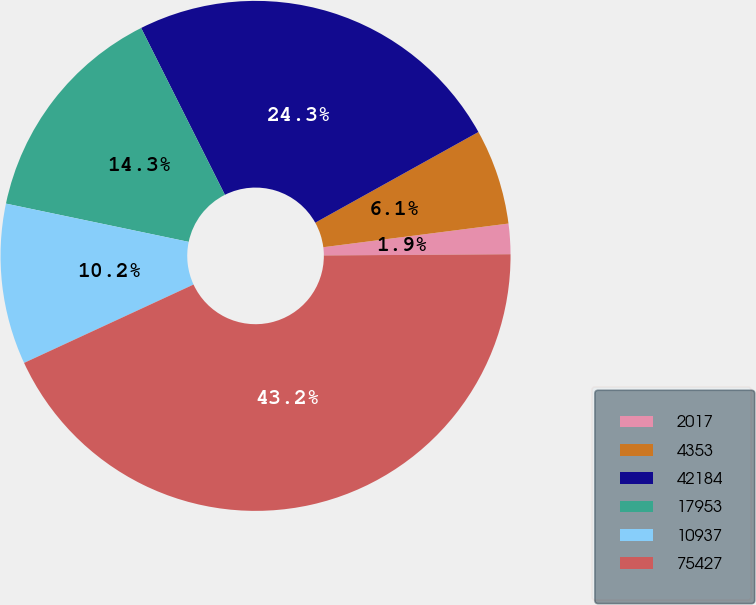Convert chart. <chart><loc_0><loc_0><loc_500><loc_500><pie_chart><fcel>2017<fcel>4353<fcel>42184<fcel>17953<fcel>10937<fcel>75427<nl><fcel>1.92%<fcel>6.05%<fcel>24.33%<fcel>14.31%<fcel>10.18%<fcel>43.21%<nl></chart> 